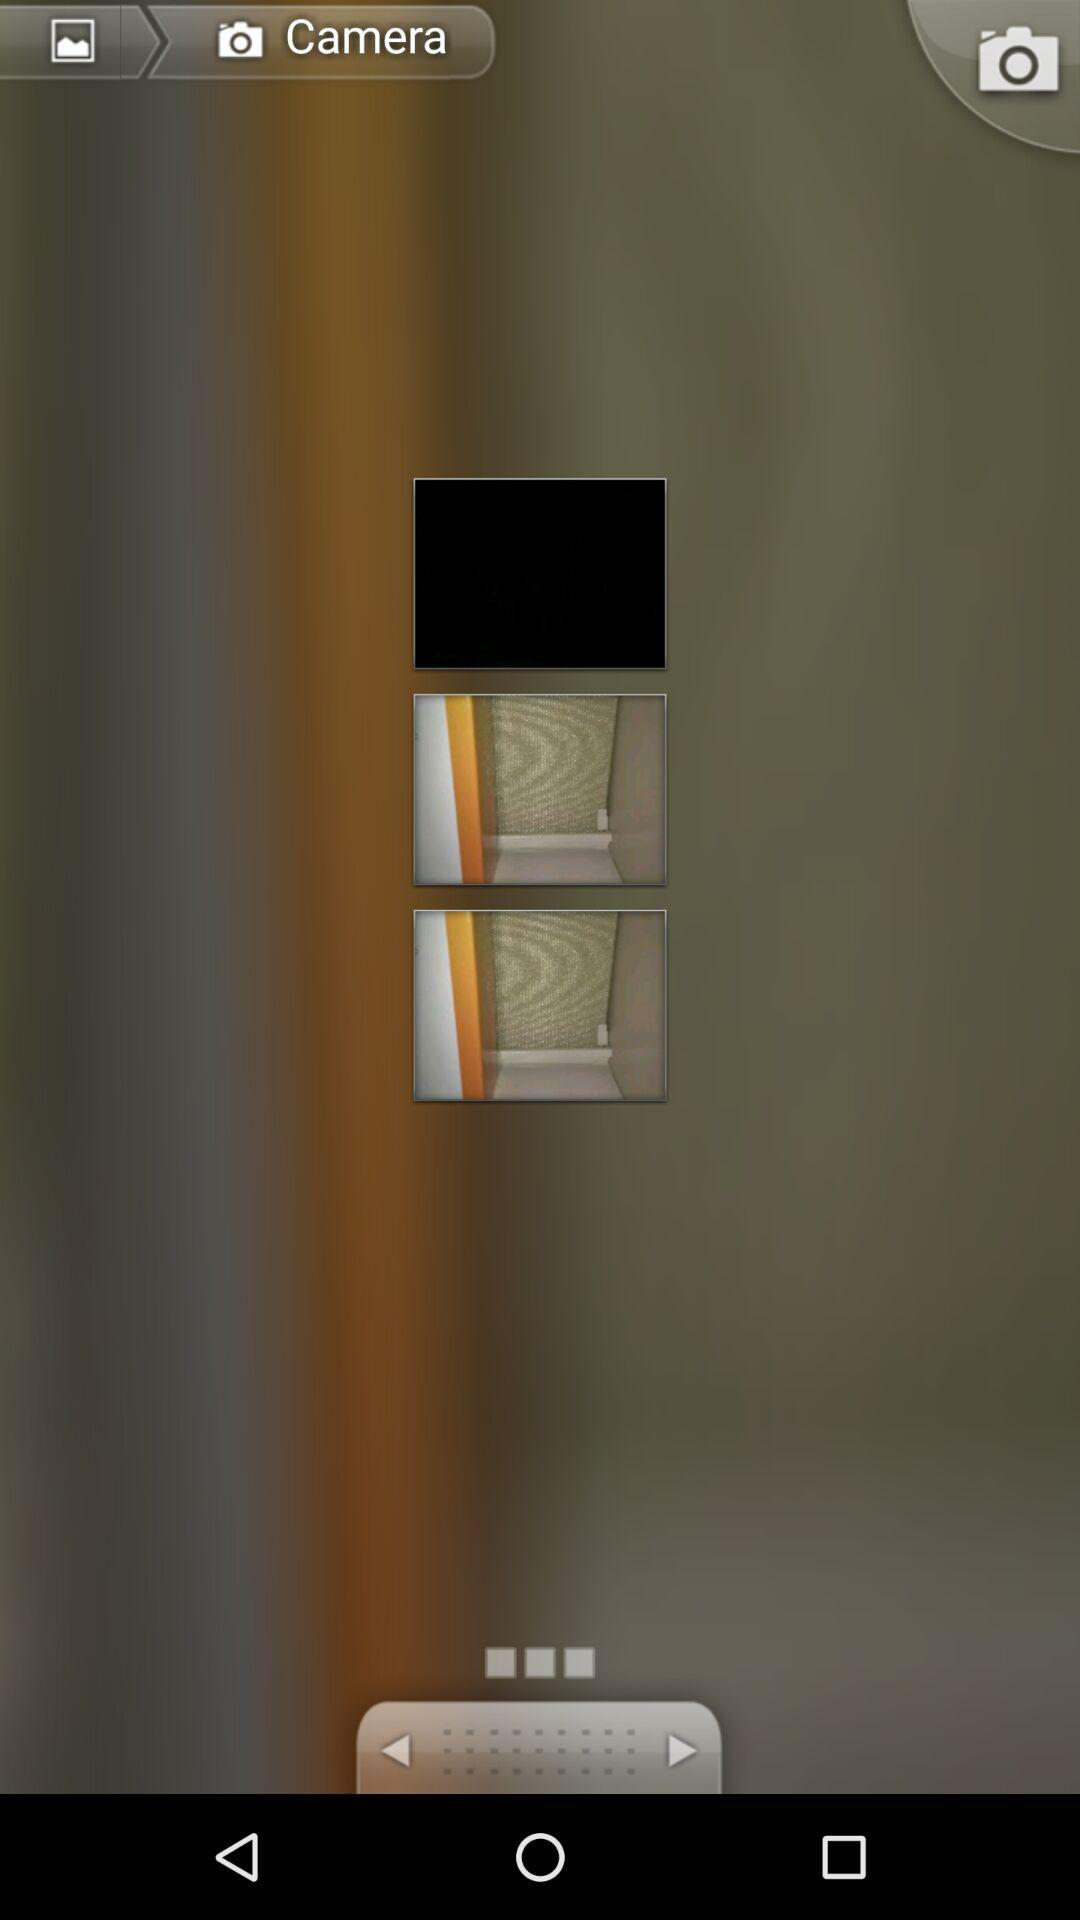How many pictures are there in the camera roll?
Answer the question using a single word or phrase. 3 